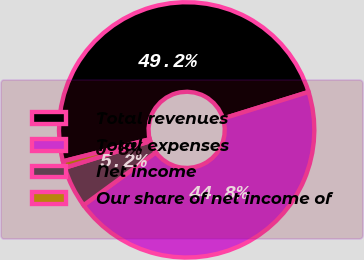<chart> <loc_0><loc_0><loc_500><loc_500><pie_chart><fcel>Total revenues<fcel>Total expenses<fcel>Net income<fcel>Our share of net income of<nl><fcel>49.16%<fcel>44.76%<fcel>5.24%<fcel>0.84%<nl></chart> 